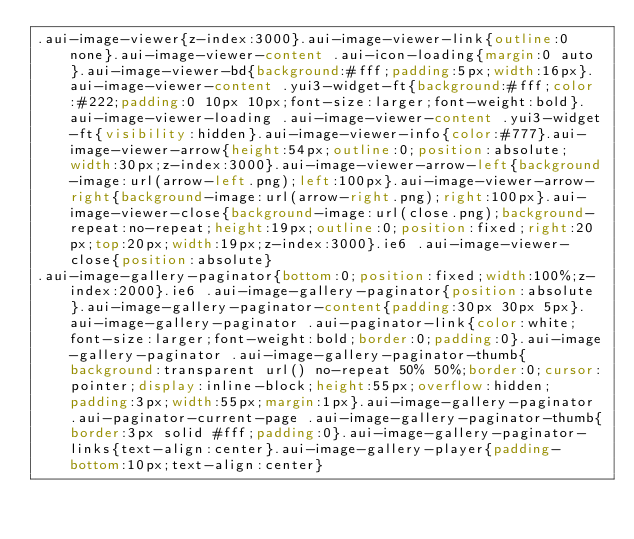Convert code to text. <code><loc_0><loc_0><loc_500><loc_500><_CSS_>.aui-image-viewer{z-index:3000}.aui-image-viewer-link{outline:0 none}.aui-image-viewer-content .aui-icon-loading{margin:0 auto}.aui-image-viewer-bd{background:#fff;padding:5px;width:16px}.aui-image-viewer-content .yui3-widget-ft{background:#fff;color:#222;padding:0 10px 10px;font-size:larger;font-weight:bold}.aui-image-viewer-loading .aui-image-viewer-content .yui3-widget-ft{visibility:hidden}.aui-image-viewer-info{color:#777}.aui-image-viewer-arrow{height:54px;outline:0;position:absolute;width:30px;z-index:3000}.aui-image-viewer-arrow-left{background-image:url(arrow-left.png);left:100px}.aui-image-viewer-arrow-right{background-image:url(arrow-right.png);right:100px}.aui-image-viewer-close{background-image:url(close.png);background-repeat:no-repeat;height:19px;outline:0;position:fixed;right:20px;top:20px;width:19px;z-index:3000}.ie6 .aui-image-viewer-close{position:absolute}
.aui-image-gallery-paginator{bottom:0;position:fixed;width:100%;z-index:2000}.ie6 .aui-image-gallery-paginator{position:absolute}.aui-image-gallery-paginator-content{padding:30px 30px 5px}.aui-image-gallery-paginator .aui-paginator-link{color:white;font-size:larger;font-weight:bold;border:0;padding:0}.aui-image-gallery-paginator .aui-image-gallery-paginator-thumb{background:transparent url() no-repeat 50% 50%;border:0;cursor:pointer;display:inline-block;height:55px;overflow:hidden;padding:3px;width:55px;margin:1px}.aui-image-gallery-paginator .aui-paginator-current-page .aui-image-gallery-paginator-thumb{border:3px solid #fff;padding:0}.aui-image-gallery-paginator-links{text-align:center}.aui-image-gallery-player{padding-bottom:10px;text-align:center}
</code> 